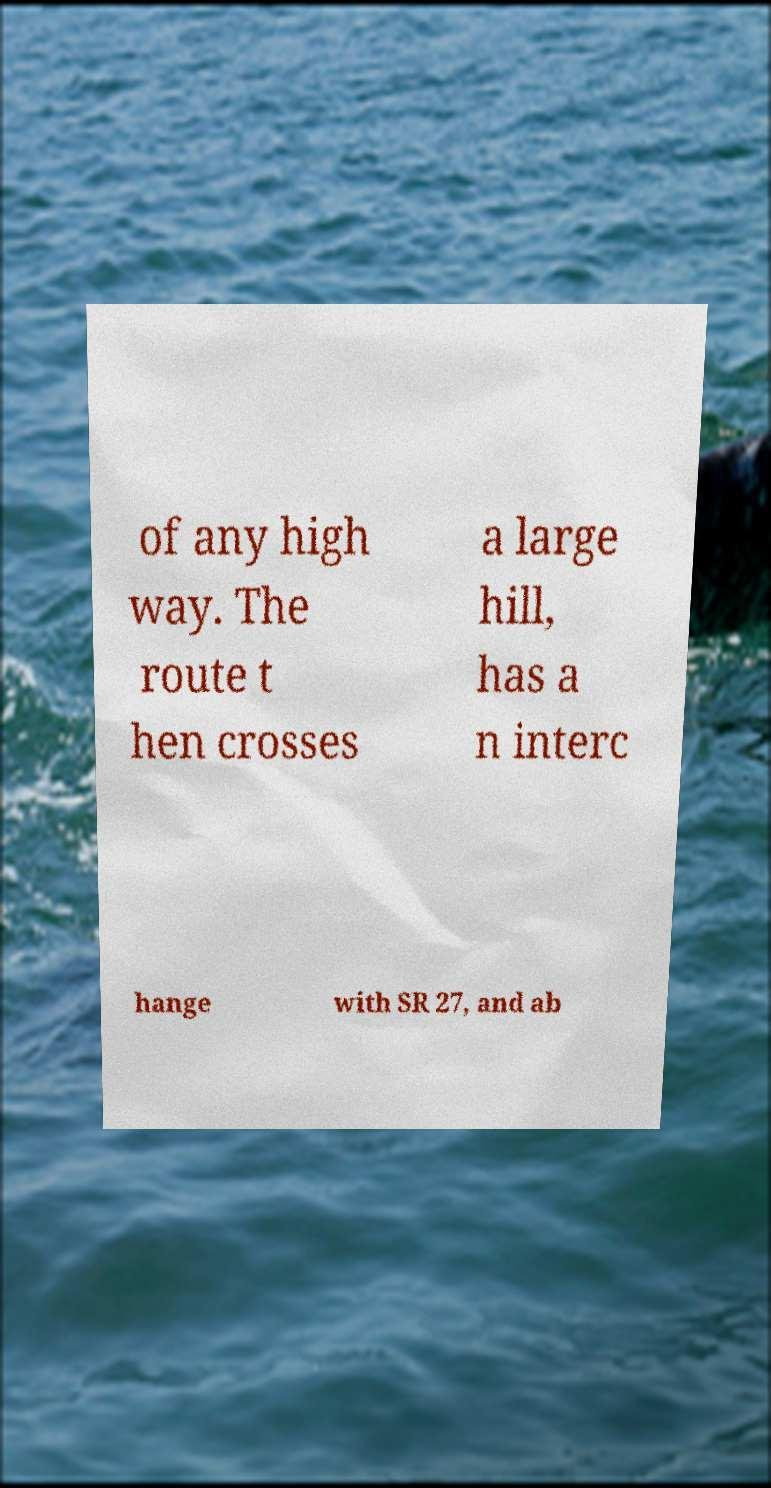Please read and relay the text visible in this image. What does it say? of any high way. The route t hen crosses a large hill, has a n interc hange with SR 27, and ab 